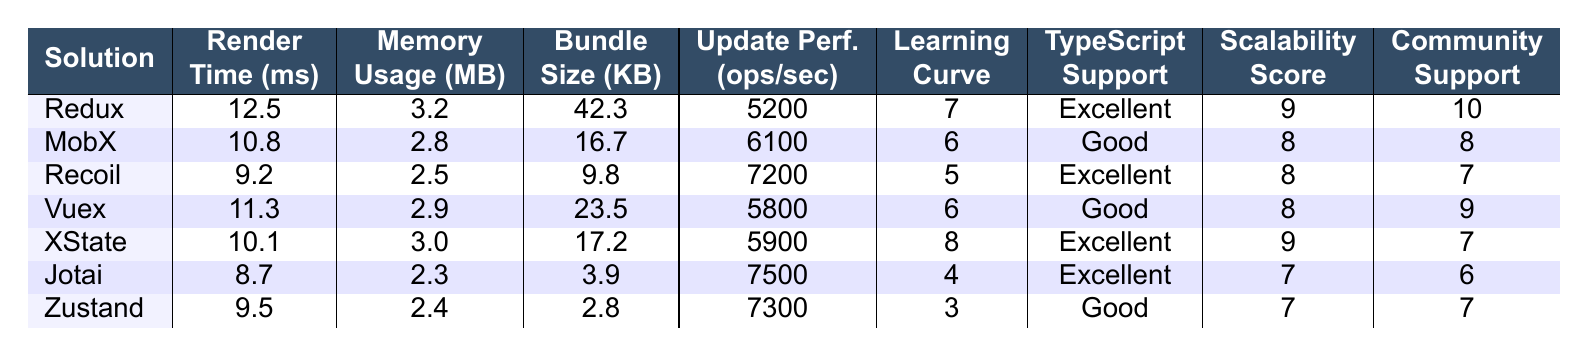What is the average render time for Redux? The table lists Redux under "State Management Solution" with an "Average Render Time" of 12.5 ms.
Answer: 12.5 ms Which state management solution has the lowest memory usage? By examining the memory usage values in the table, Jotai has the lowest memory usage at 2.3 MB.
Answer: Jotai What is the bundle size of MobX? The table indicates that MobX has a "Bundle Size" of 16.7 KB listed under its row.
Answer: 16.7 KB Which solution has the highest update performance, and what is the value? Looking at the "Update Performance" column, Jotai scores the highest at 7500 ops/sec.
Answer: Jotai, 7500 ops/sec How does the scalability score of Redux compare to that of Vuex? Redux has a scalability score of 9, while Vuex has a score of 8; therefore, Redux has a higher scalability score than Vuex.
Answer: Redux is higher What is the average learning curve rating for all listed solutions? Summing the learning curve scores (7 + 6 + 5 + 6 + 8 + 4 + 3) = 39; there are 7 solutions, so dividing 39 by 7 gives approximately 5.57.
Answer: 5.57 Does any state management solution have "Excellent" TypeScript support and a learning curve rating lower than 5? Jotai and Recoil have "Excellent" TypeScript support; however, Jotai has a learning curve rating of 4, which is lower than 5.
Answer: Yes, Jotai Which state management solution has the best community support score and how much is it? The community support score for Redux is 10, which is the highest among all solutions listed.
Answer: Redux, 10 What is the difference in average render time between Recoil and Zustand? Recoil's average render time is 9.2 ms and Zustand's average render time is 9.5 ms; thus, the difference is 9.5 ms - 9.2 ms = 0.3 ms, indicating Recoil is faster.
Answer: 0.3 ms Which solution has better TypeScript support: MobX or XState? MobX has "Good" TypeScript support whereas XState has "Excellent" TypeScript support; thus, XState offers better TypeScript support than MobX.
Answer: XState is better 